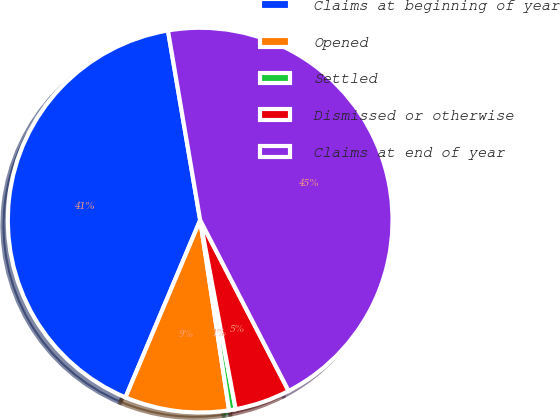<chart> <loc_0><loc_0><loc_500><loc_500><pie_chart><fcel>Claims at beginning of year<fcel>Opened<fcel>Settled<fcel>Dismissed or otherwise<fcel>Claims at end of year<nl><fcel>40.98%<fcel>8.75%<fcel>0.55%<fcel>4.65%<fcel>45.08%<nl></chart> 